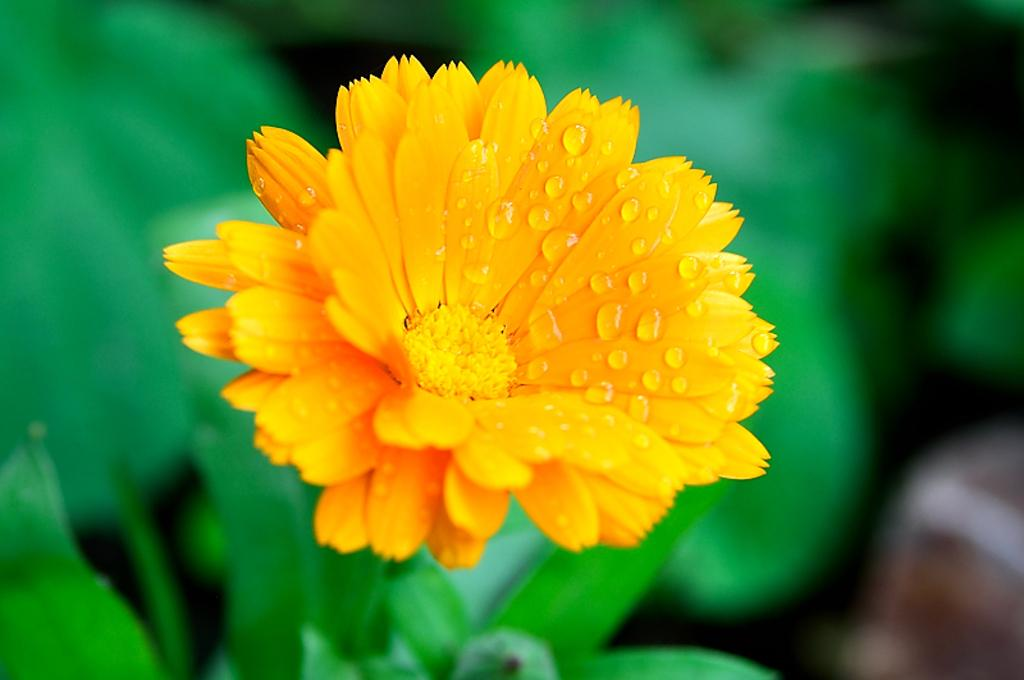What type of plant is visible in the image? There is a flower in the image. What other part of the plant can be seen in the image? There are leaves in the image. Can you describe the background of the image? The background of the image is blurry. How many dolls can be seen interacting with the dinosaurs in the image? There are no dolls or dinosaurs present in the image. 